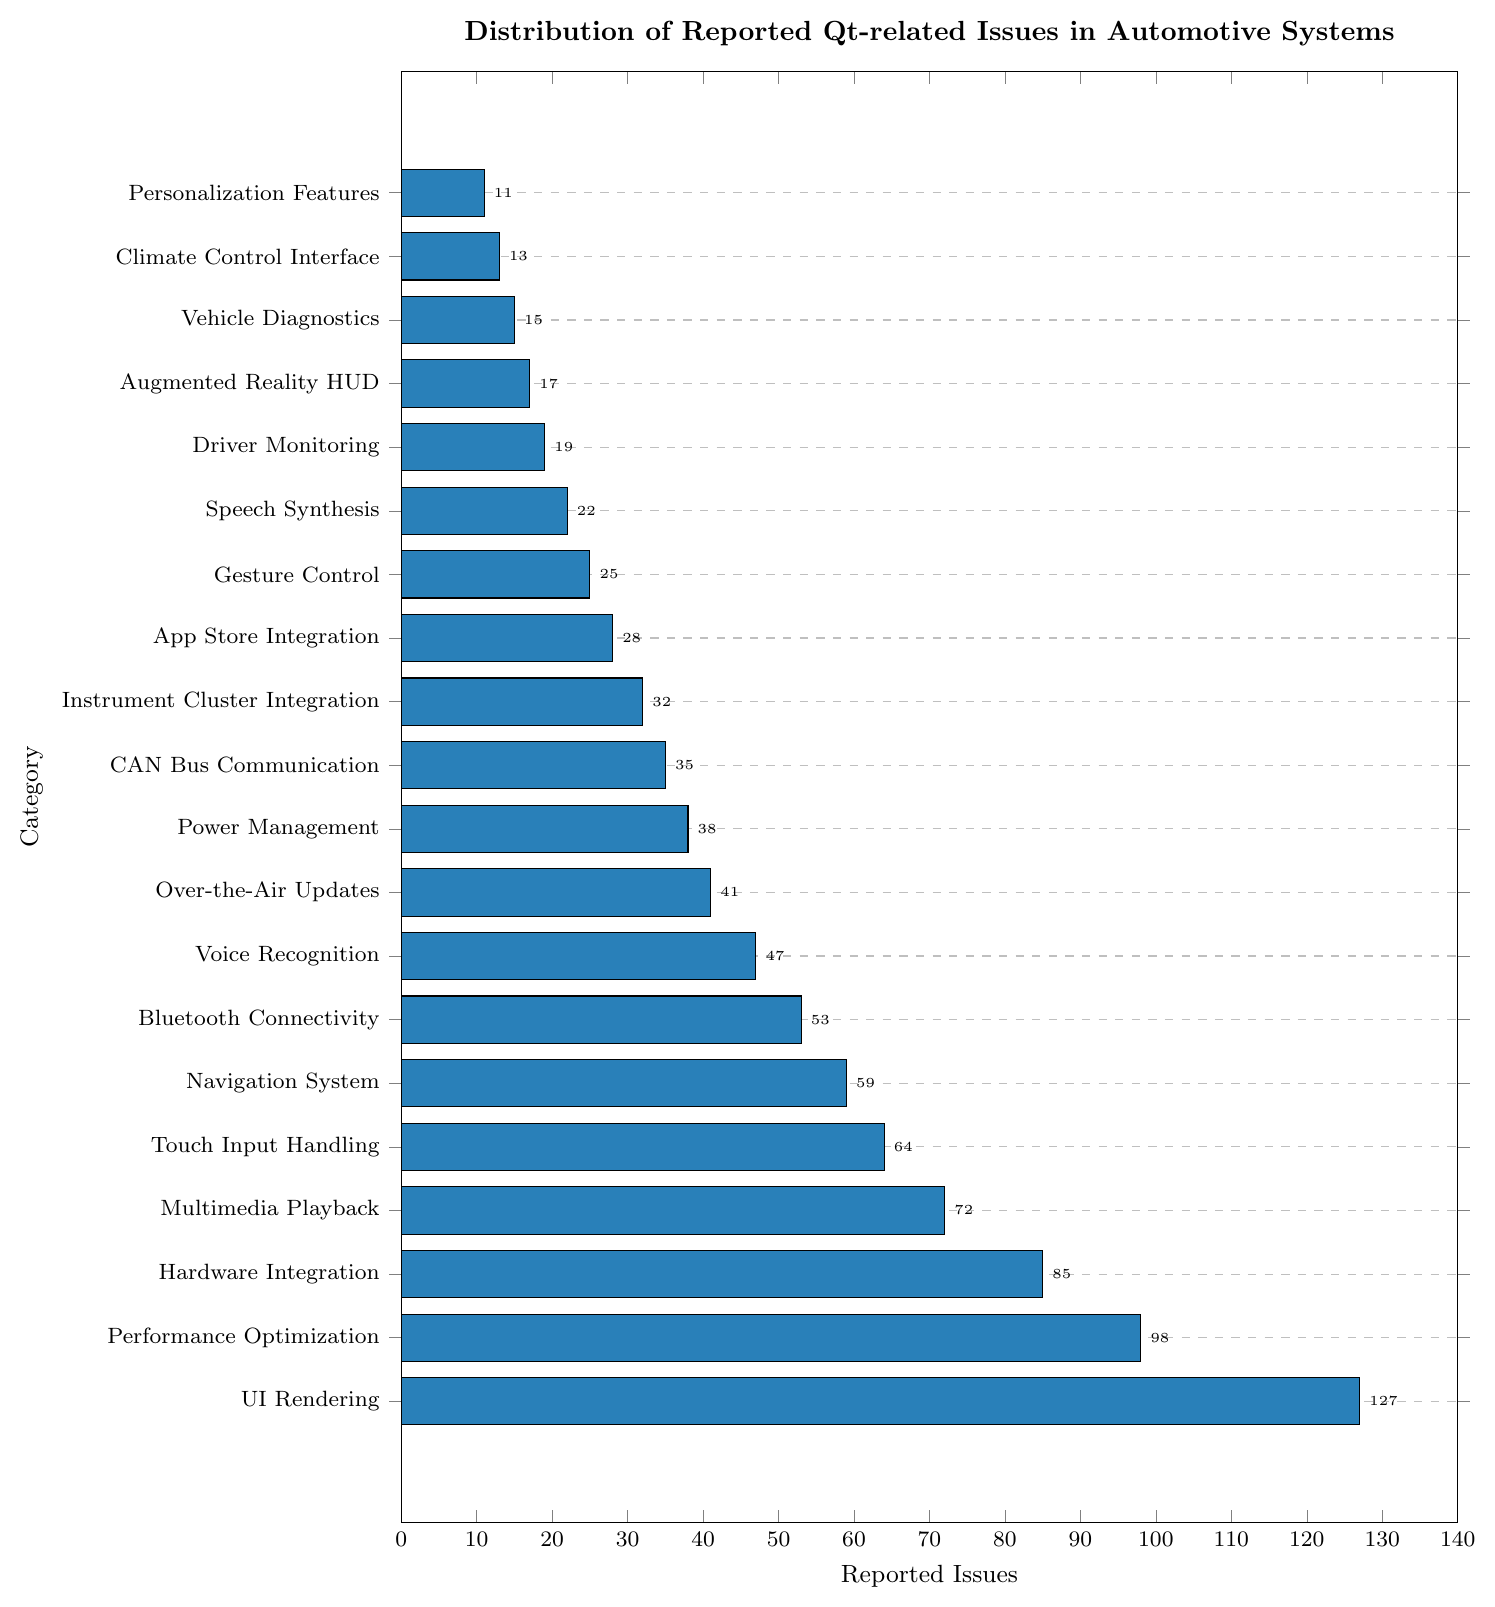Which category has the highest number of reported issues? The category with the longest bar represents the highest number of reported issues. "UI Rendering" has the longest bar.
Answer: UI Rendering What is the total number of reported issues for “Bluetooth Connectivity” and “Voice Recognition” combined? Add the reported issues for "Bluetooth Connectivity" (53) and "Voice Recognition" (47). The sum is 53 + 47 = 100.
Answer: 100 How does the number of reported issues in "Performance Optimization" compare to "Hardware Integration”? Compare the values for "Performance Optimization" (98) and "Hardware Integration" (85). 98 is greater than 85.
Answer: Performance Optimization has more issues Which category has fewer reported issues: "Gesture Control" or "Personalization Features"? Compare the values for "Gesture Control" (25) and "Personalization Features" (11). 11 is less than 25.
Answer: Personalization Features What is the median value of the reported issues for all categories? List all values in ascending order: 11, 13, 15, 17, 19, 22, 25, 28, 32, 35, 38, 41, 47, 53, 59, 64, 72, 85, 98, 127. Since there are 20 values, the median is the average of the 10th and 11th values: (35 + 38)/2 = 36.5.
Answer: 36.5 How many categories have reported issues greater than 50? Count all categories with reported issues over 50: "UI Rendering", "Performance Optimization", "Hardware Integration", "Multimedia Playback", "Touch Input Handling", "Navigation System", "Bluetooth Connectivity", and "Voice Recognition." There are 8 such categories.
Answer: 8 What is the percentage of "Over-the-Air Updates" issues relative to the total number of reported issues? Calculate the total number of reported issues by summing all values: 11 + 13 + 15 + 17 + 19 + 22 + 25 + 28 + 32 + 35 + 38 + 41 + 47 + 53 + 59 + 64 + 72 + 85 + 98 + 127 = 902. Then, find the percentage: (41/902) * 100 ≈ 4.55%.
Answer: 4.55% Which category has a more substantial visual representation: “Climate Control Interface” or "Vehicle Diagnostics"? Compare the bar lengths of "Climate Control Interface" (13) and "Vehicle Diagnostics" (15). The bar for "Vehicle Diagnostics" is slightly longer.
Answer: Vehicle Diagnostics 